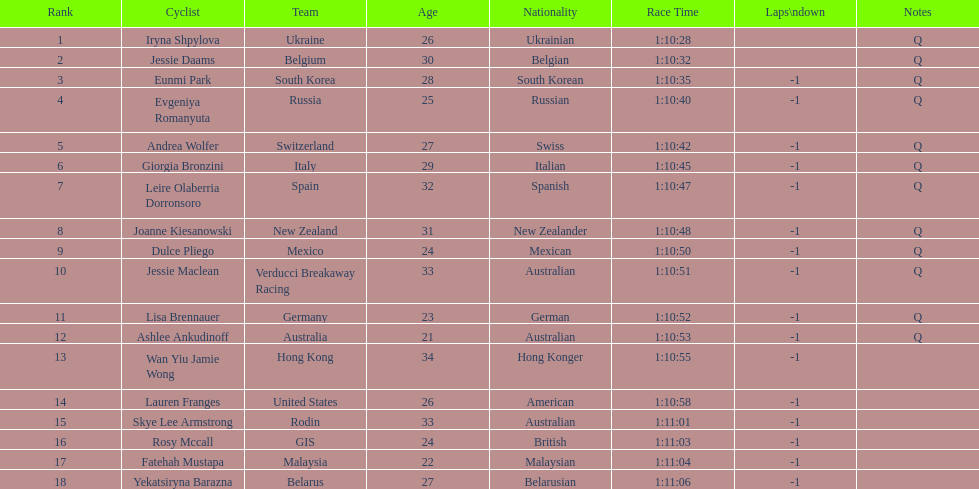How many cyclist are not listed with a country team? 3. 